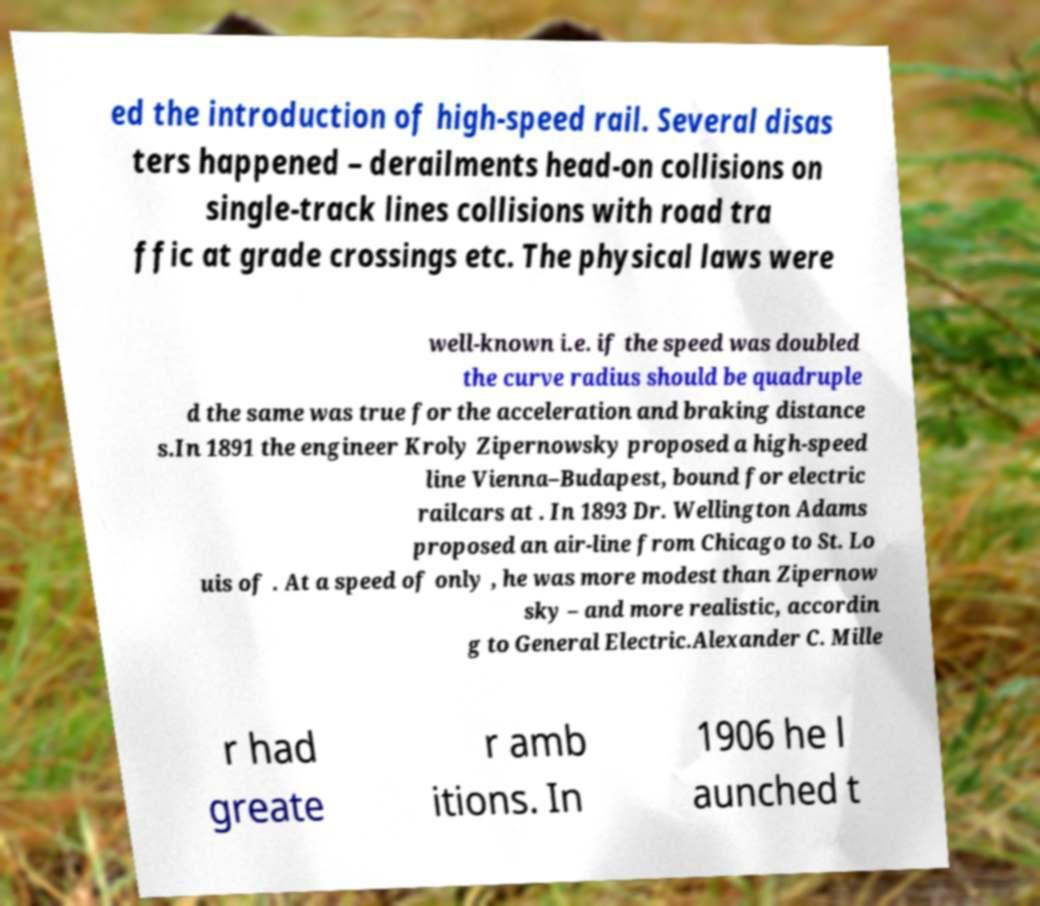Please identify and transcribe the text found in this image. ed the introduction of high-speed rail. Several disas ters happened – derailments head-on collisions on single-track lines collisions with road tra ffic at grade crossings etc. The physical laws were well-known i.e. if the speed was doubled the curve radius should be quadruple d the same was true for the acceleration and braking distance s.In 1891 the engineer Kroly Zipernowsky proposed a high-speed line Vienna–Budapest, bound for electric railcars at . In 1893 Dr. Wellington Adams proposed an air-line from Chicago to St. Lo uis of . At a speed of only , he was more modest than Zipernow sky – and more realistic, accordin g to General Electric.Alexander C. Mille r had greate r amb itions. In 1906 he l aunched t 